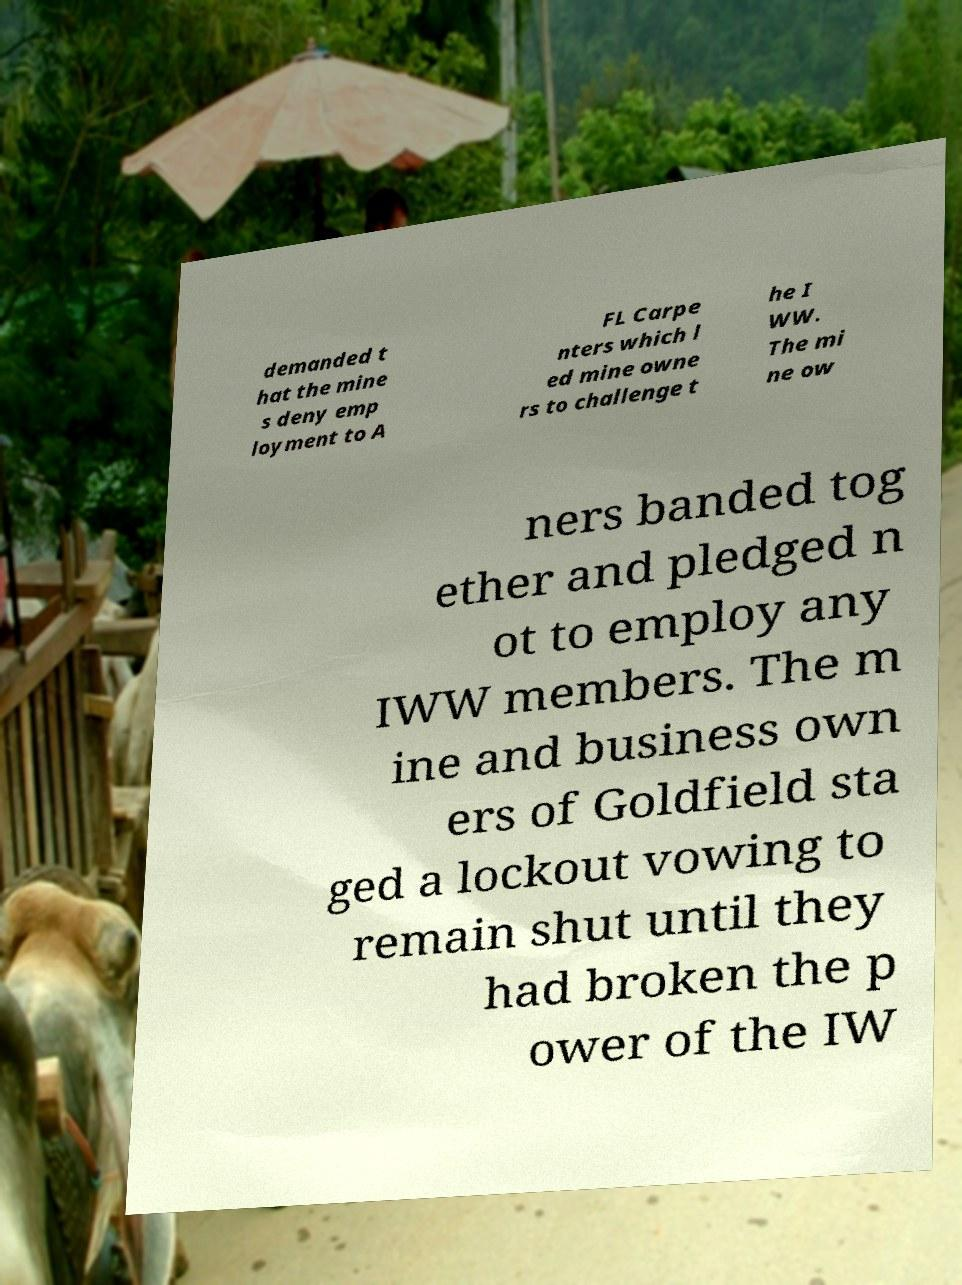Can you accurately transcribe the text from the provided image for me? demanded t hat the mine s deny emp loyment to A FL Carpe nters which l ed mine owne rs to challenge t he I WW. The mi ne ow ners banded tog ether and pledged n ot to employ any IWW members. The m ine and business own ers of Goldfield sta ged a lockout vowing to remain shut until they had broken the p ower of the IW 